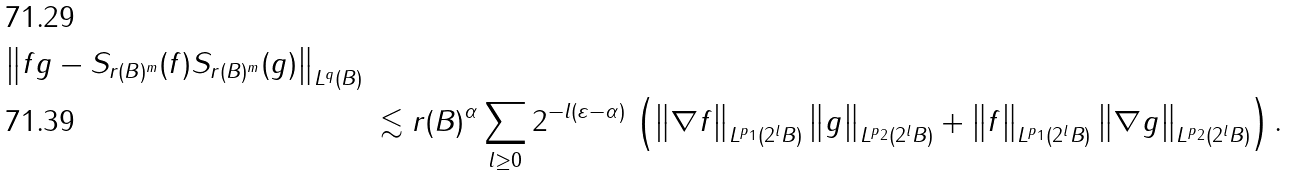<formula> <loc_0><loc_0><loc_500><loc_500>{ \left \| f g - S _ { r ( B ) ^ { m } } ( f ) S _ { r ( B ) ^ { m } } ( g ) \right \| _ { L ^ { q } ( B ) } } & & \\ & & \lesssim r ( B ) ^ { \alpha } \sum _ { l \geq 0 } 2 ^ { - l ( \varepsilon - \alpha ) } \, \left ( \left \| \nabla f \right \| _ { L ^ { p _ { 1 } } ( 2 ^ { l } B ) } \left \| g \right \| _ { L ^ { p _ { 2 } } ( 2 ^ { l } B ) } + \left \| f \right \| _ { L ^ { p _ { 1 } } ( 2 ^ { l } B ) } \left \| \nabla g \right \| _ { L ^ { p _ { 2 } } ( 2 ^ { l } B ) } \right ) .</formula> 